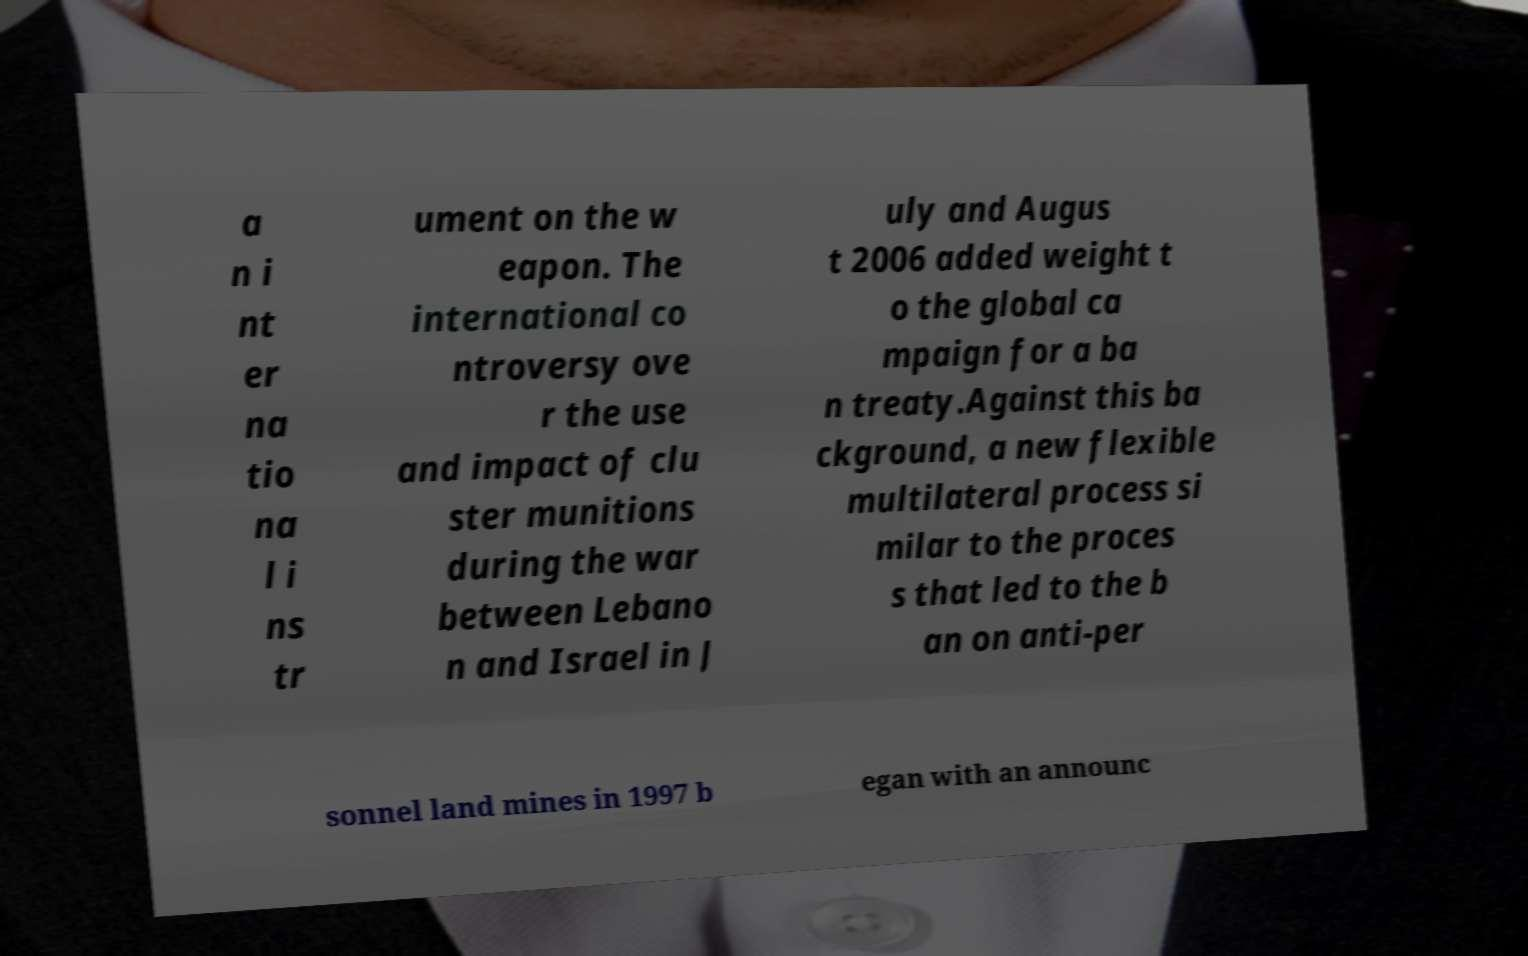Please read and relay the text visible in this image. What does it say? a n i nt er na tio na l i ns tr ument on the w eapon. The international co ntroversy ove r the use and impact of clu ster munitions during the war between Lebano n and Israel in J uly and Augus t 2006 added weight t o the global ca mpaign for a ba n treaty.Against this ba ckground, a new flexible multilateral process si milar to the proces s that led to the b an on anti-per sonnel land mines in 1997 b egan with an announc 